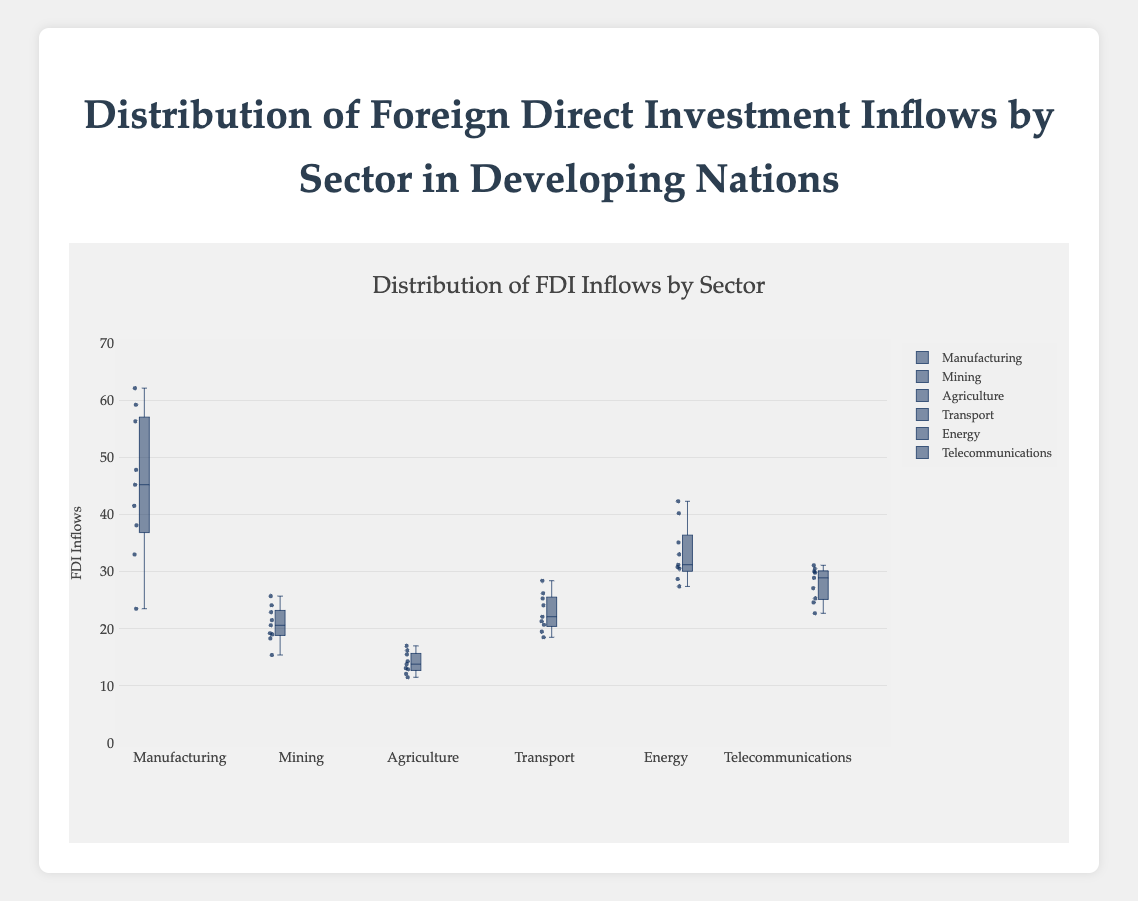Which sector has the highest median FDI inflow? To find the highest median FDI inflow, look at the median line inside each box. The Manufacturing sector has the highest median line compared to other sectors.
Answer: Manufacturing Which sector shows the widest range of FDI inflow values? The range of values is indicated by the distance between the bottom and top whiskers. Manufacturing has the widest range among the sectors.
Answer: Manufacturing How does the median FDI inflow in the Telecommunications sector compare to the Energy sector? Compare the median lines within the boxes of both sectors. The median FDI inflow for Telecommunications is lower than that for the Energy sector.
Answer: Telecommunications is lower than Energy What is the interquartile range (IQR) for the Energy sector? The IQR is the distance between the first quartile (Q1) and the third quartile (Q3) inside the box. For the Energy sector, IQR is approximately 31 to 35, so IQR = 35 - 31 = 4.
Answer: 4 Which sector has the smallest variation in FDI inflows as shown by the interquartile range? The smallest variation is represented by the smallest box, indicating minimal spread between Q1 and Q3. Agriculture has the smallest IQR.
Answer: Agriculture Is the mean FDI inflow for the Transport sector above its median? In the box plot, if there are more outliers or a longer whisker on one side of the box, it affects the mean. For Transport, the distribution appears relatively balanced, suggesting the mean might be near the median. This is not definitively answerable from the box plot alone but can be inferred.
Answer: Not definitive but likely near the median Which sector received the highest single FDI inflow value? The highest single FDI inflow value is represented by the top whisker or an outlier. Manufacturing shows the highest single value, around 62.1.
Answer: Manufacturing How do the FDI inflows for Mining compare to Agriculture in terms of spread? Compare the lengths of the boxes and whiskers. Mining has a wider range and more spread-out values compared to Agriculture.
Answer: Mining has a wider spread than Agriculture What are the minimum and maximum values of FDI inflows in the Telecommunications sector? The minimum and maximum values are indicated by the bottom and top whiskers. For Telecommunications, the values are approximately 22.7 and 31.1.
Answer: Min: 22.7, Max: 31.1 